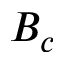<formula> <loc_0><loc_0><loc_500><loc_500>B _ { c }</formula> 